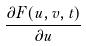<formula> <loc_0><loc_0><loc_500><loc_500>\frac { \partial F ( u , v , t ) } { \partial u }</formula> 